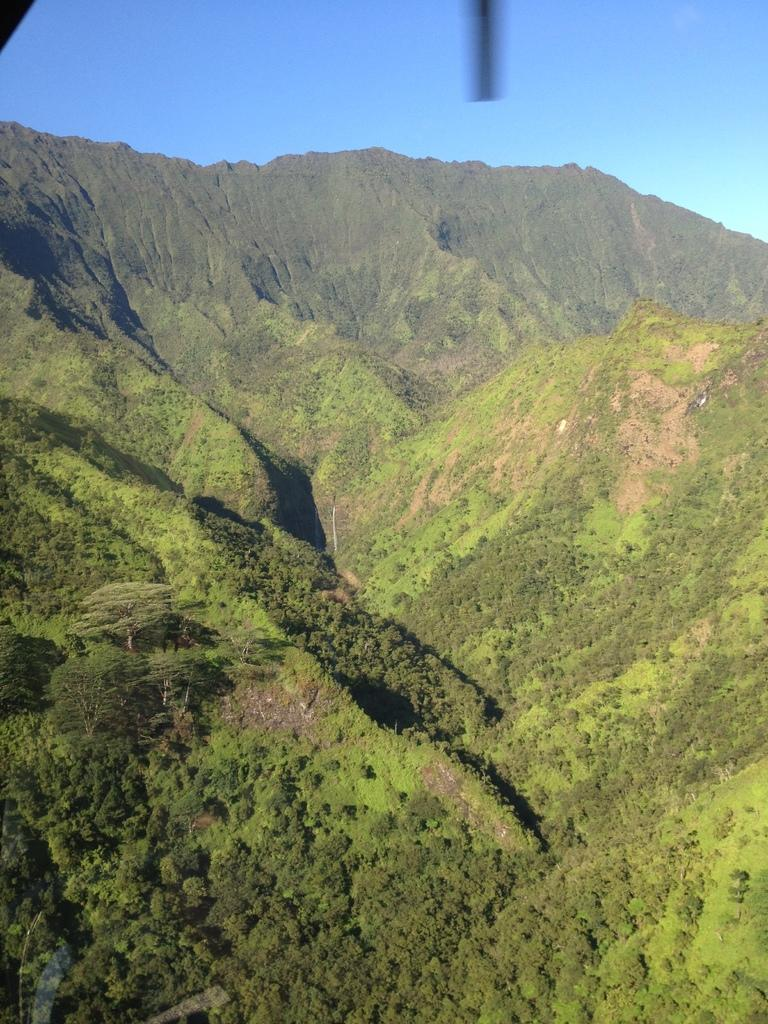What type of natural formation can be seen in the image? There are mountains in the image. What is present on the mountains in the image? There are trees on the mountains. What is visible at the top of the image? The sky is visible at the top of the image. What type of party is happening on the mountains in the image? There is no party present in the image; it features mountains with trees and a visible sky. 